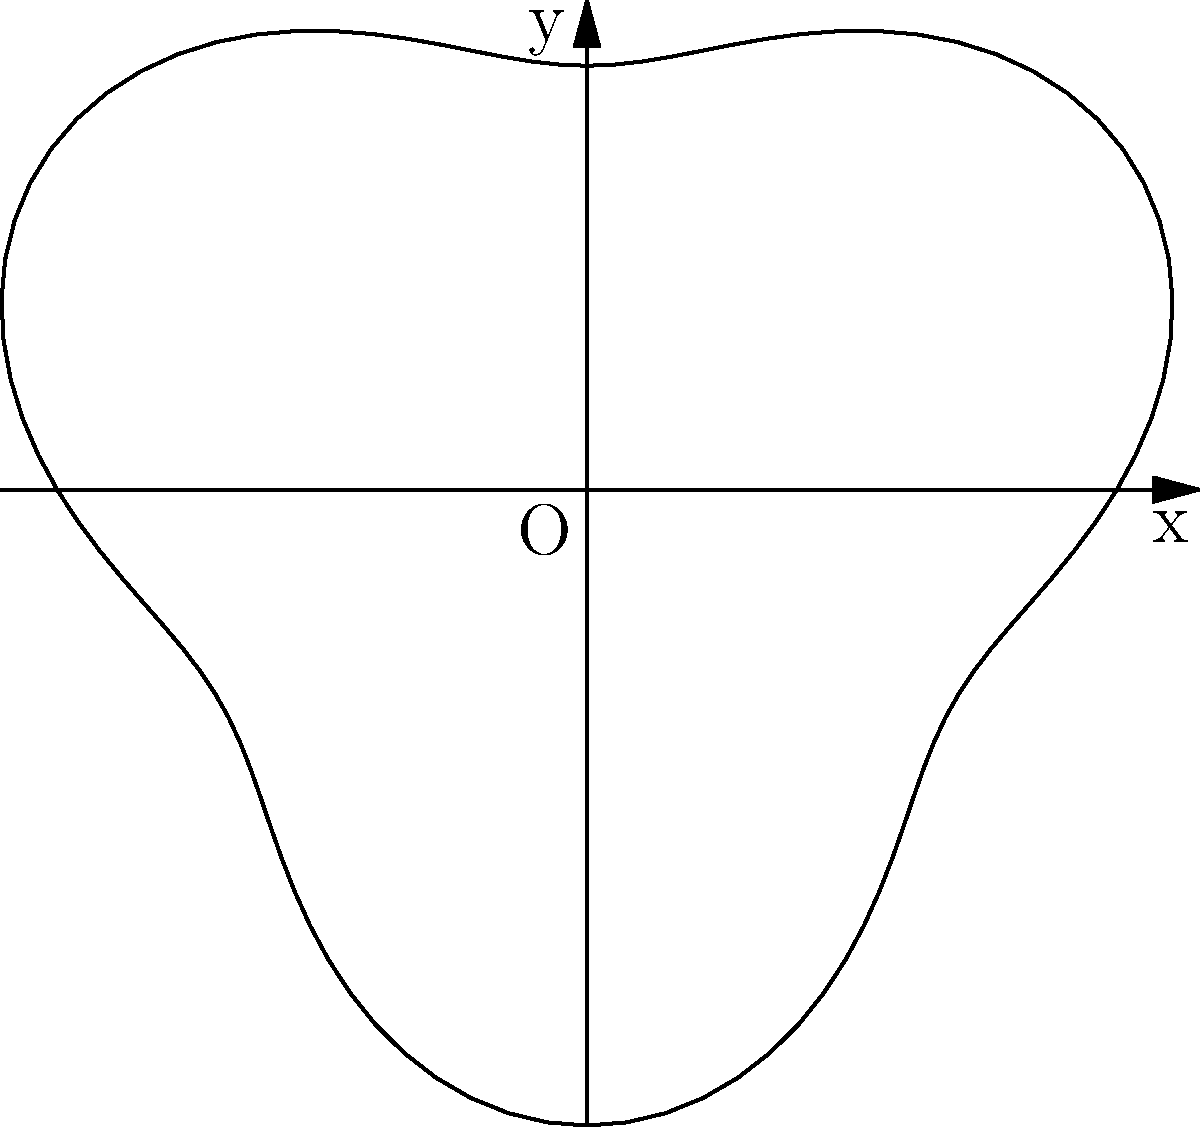As the class president, you're tasked with calculating the area of the school's new irregular-shaped grounds for budget allocation purposes. The boundary of the grounds can be described in polar coordinates by the equation $r = 50 + 10\sin(3\theta)$, where $r$ is in meters. Calculate the total area of the school grounds in square meters. To calculate the area of the irregular school grounds using polar coordinates, we'll follow these steps:

1) The formula for the area of a region in polar coordinates is:

   $$A = \frac{1}{2} \int_{0}^{2\pi} r^2(\theta) d\theta$$

2) In our case, $r(\theta) = 50 + 10\sin(3\theta)$

3) We need to square this function:

   $$r^2(\theta) = (50 + 10\sin(3\theta))^2 = 2500 + 1000\sin(3\theta) + 100\sin^2(3\theta)$$

4) Now, let's set up the integral:

   $$A = \frac{1}{2} \int_{0}^{2\pi} (2500 + 1000\sin(3\theta) + 100\sin^2(3\theta)) d\theta$$

5) Let's integrate each term separately:
   
   - $\int_{0}^{2\pi} 2500 d\theta = 2500\theta \big|_{0}^{2\pi} = 5000\pi$
   
   - $\int_{0}^{2\pi} 1000\sin(3\theta) d\theta = -\frac{1000}{3}\cos(3\theta) \big|_{0}^{2\pi} = 0$
   
   - $\int_{0}^{2\pi} 100\sin^2(3\theta) d\theta = 50\int_{0}^{2\pi} (1 - \cos(6\theta)) d\theta = 50\theta - \frac{50}{6}\sin(6\theta) \big|_{0}^{2\pi} = 100\pi$

6) Adding these results:

   $$A = \frac{1}{2} (5000\pi + 0 + 100\pi) = 2550\pi$$

Therefore, the total area of the school grounds is $2550\pi$ square meters.
Answer: $2550\pi$ square meters 